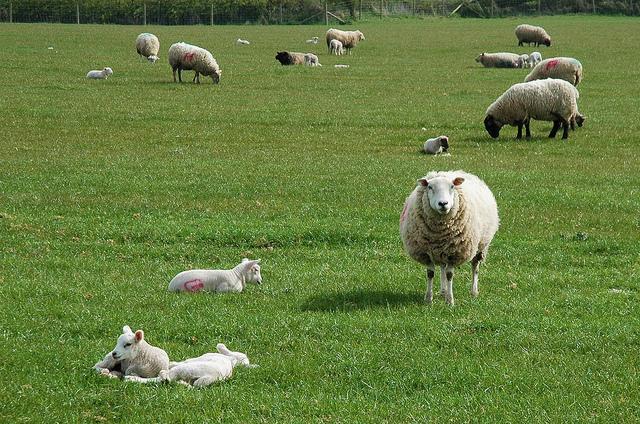How many sheep can be seen?
Give a very brief answer. 6. 